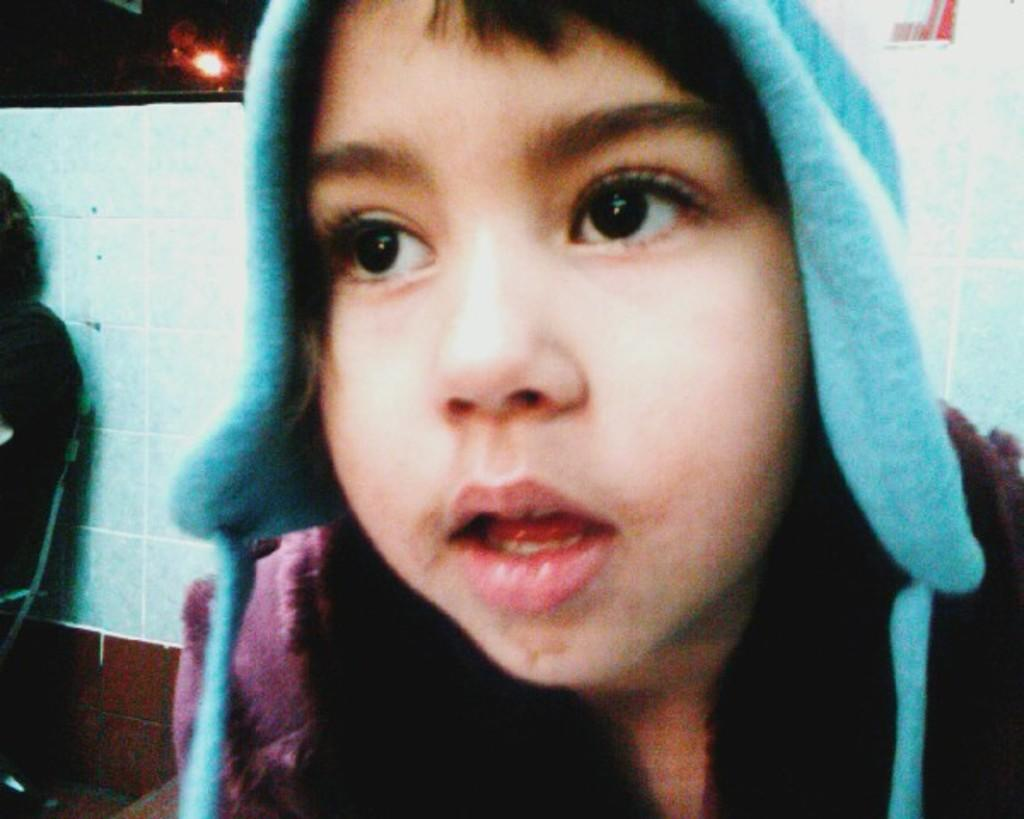Who is the main subject in the image? There is a boy in the center of the image. What can be seen in the background of the image? There is a tile wall and a person sitting on a chair in the background of the image. Can you describe the lighting in the image? There is a light visible in the image. How many sheep are visible in the image? There are no sheep present in the image. What type of leaf is being used as a prop by the boy in the image? There is no leaf present in the image. 